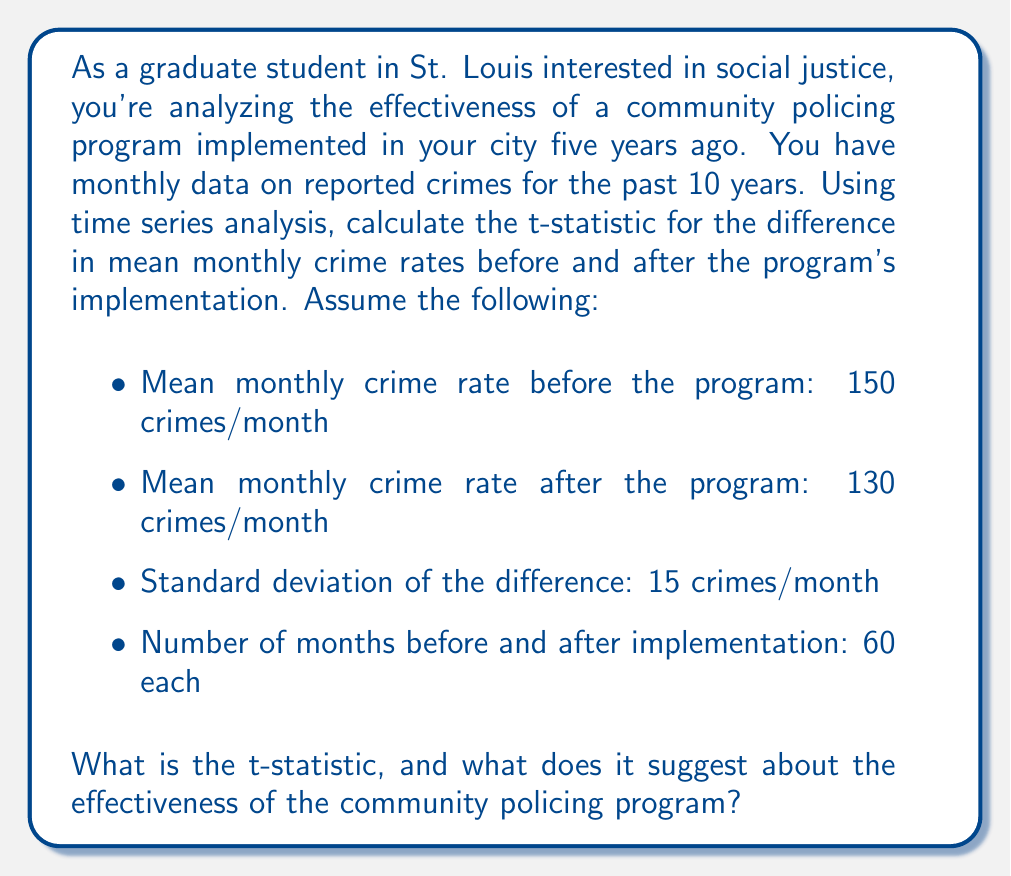Give your solution to this math problem. To evaluate the effectiveness of the community policing program using time series analysis, we'll calculate the t-statistic for the difference in mean monthly crime rates before and after the program's implementation. This approach helps us determine if the observed difference is statistically significant.

Step 1: Identify the relevant information
- $\mu_1$ (mean before) = 150 crimes/month
- $\mu_2$ (mean after) = 130 crimes/month
- $s_d$ (standard deviation of the difference) = 15 crimes/month
- $n_1 = n_2 = 60$ months

Step 2: Calculate the difference in means
$$\bar{d} = \mu_1 - \mu_2 = 150 - 130 = 20 \text{ crimes/month}$$

Step 3: Calculate the standard error of the difference
The standard error (SE) is given by:
$$SE = \frac{s_d}{\sqrt{n}}$$
Where n is the number of paired observations (60 in this case).

$$SE = \frac{15}{\sqrt{60}} = \frac{15}{7.746} \approx 1.936$$

Step 4: Calculate the t-statistic
The t-statistic is calculated using the formula:
$$t = \frac{\bar{d}}{SE}$$

Substituting our values:
$$t = \frac{20}{1.936} \approx 10.33$$

Step 5: Interpret the results
The t-statistic of 10.33 is relatively large, suggesting a significant difference between the mean crime rates before and after the implementation of the community policing program. To confirm statistical significance, you would compare this t-value to the critical value from a t-distribution table, using the appropriate degrees of freedom (df = 59) and desired significance level (e.g., α = 0.05).

In this case, the t-statistic is much larger than the critical value for any common significance level, indicating strong evidence that the community policing program has been effective in reducing crime rates in St. Louis.
Answer: The t-statistic is approximately 10.33. This large t-value suggests that the community policing program has been effective in significantly reducing crime rates in St. Louis, as the difference in mean monthly crime rates before and after the program's implementation is statistically significant. 